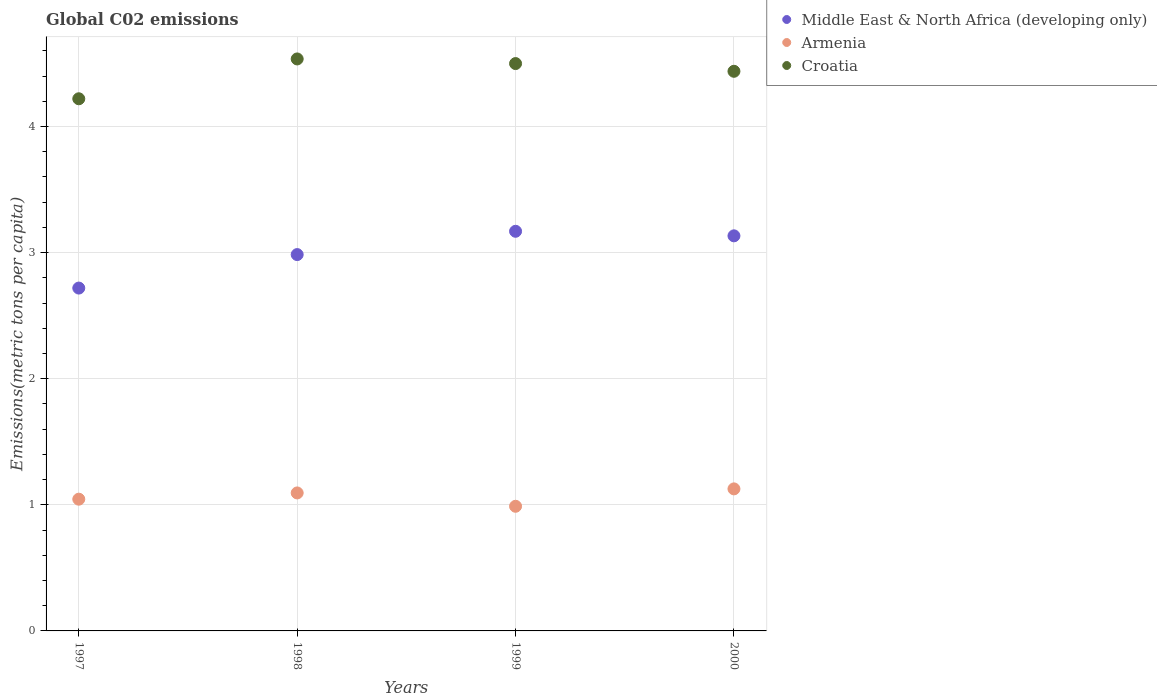What is the amount of CO2 emitted in in Middle East & North Africa (developing only) in 1998?
Provide a succinct answer. 2.98. Across all years, what is the maximum amount of CO2 emitted in in Armenia?
Keep it short and to the point. 1.13. Across all years, what is the minimum amount of CO2 emitted in in Middle East & North Africa (developing only)?
Give a very brief answer. 2.72. What is the total amount of CO2 emitted in in Armenia in the graph?
Your response must be concise. 4.25. What is the difference between the amount of CO2 emitted in in Armenia in 1997 and that in 1998?
Give a very brief answer. -0.05. What is the difference between the amount of CO2 emitted in in Croatia in 1999 and the amount of CO2 emitted in in Armenia in 2000?
Your answer should be compact. 3.37. What is the average amount of CO2 emitted in in Armenia per year?
Ensure brevity in your answer.  1.06. In the year 1999, what is the difference between the amount of CO2 emitted in in Middle East & North Africa (developing only) and amount of CO2 emitted in in Croatia?
Offer a terse response. -1.33. What is the ratio of the amount of CO2 emitted in in Armenia in 1997 to that in 1998?
Your answer should be very brief. 0.95. Is the difference between the amount of CO2 emitted in in Middle East & North Africa (developing only) in 1997 and 2000 greater than the difference between the amount of CO2 emitted in in Croatia in 1997 and 2000?
Make the answer very short. No. What is the difference between the highest and the second highest amount of CO2 emitted in in Croatia?
Your answer should be very brief. 0.04. What is the difference between the highest and the lowest amount of CO2 emitted in in Middle East & North Africa (developing only)?
Give a very brief answer. 0.45. In how many years, is the amount of CO2 emitted in in Middle East & North Africa (developing only) greater than the average amount of CO2 emitted in in Middle East & North Africa (developing only) taken over all years?
Give a very brief answer. 2. Is it the case that in every year, the sum of the amount of CO2 emitted in in Croatia and amount of CO2 emitted in in Middle East & North Africa (developing only)  is greater than the amount of CO2 emitted in in Armenia?
Provide a short and direct response. Yes. Is the amount of CO2 emitted in in Croatia strictly less than the amount of CO2 emitted in in Armenia over the years?
Give a very brief answer. No. How many years are there in the graph?
Ensure brevity in your answer.  4. Are the values on the major ticks of Y-axis written in scientific E-notation?
Provide a succinct answer. No. Where does the legend appear in the graph?
Ensure brevity in your answer.  Top right. How many legend labels are there?
Make the answer very short. 3. What is the title of the graph?
Your answer should be compact. Global C02 emissions. Does "European Union" appear as one of the legend labels in the graph?
Offer a very short reply. No. What is the label or title of the Y-axis?
Give a very brief answer. Emissions(metric tons per capita). What is the Emissions(metric tons per capita) in Middle East & North Africa (developing only) in 1997?
Your response must be concise. 2.72. What is the Emissions(metric tons per capita) in Armenia in 1997?
Your answer should be compact. 1.04. What is the Emissions(metric tons per capita) of Croatia in 1997?
Make the answer very short. 4.22. What is the Emissions(metric tons per capita) in Middle East & North Africa (developing only) in 1998?
Your answer should be very brief. 2.98. What is the Emissions(metric tons per capita) in Armenia in 1998?
Your answer should be compact. 1.09. What is the Emissions(metric tons per capita) in Croatia in 1998?
Ensure brevity in your answer.  4.54. What is the Emissions(metric tons per capita) of Middle East & North Africa (developing only) in 1999?
Make the answer very short. 3.17. What is the Emissions(metric tons per capita) of Armenia in 1999?
Provide a short and direct response. 0.99. What is the Emissions(metric tons per capita) of Croatia in 1999?
Your response must be concise. 4.5. What is the Emissions(metric tons per capita) in Middle East & North Africa (developing only) in 2000?
Offer a very short reply. 3.13. What is the Emissions(metric tons per capita) of Armenia in 2000?
Offer a terse response. 1.13. What is the Emissions(metric tons per capita) of Croatia in 2000?
Offer a terse response. 4.44. Across all years, what is the maximum Emissions(metric tons per capita) of Middle East & North Africa (developing only)?
Offer a very short reply. 3.17. Across all years, what is the maximum Emissions(metric tons per capita) of Armenia?
Provide a succinct answer. 1.13. Across all years, what is the maximum Emissions(metric tons per capita) of Croatia?
Provide a short and direct response. 4.54. Across all years, what is the minimum Emissions(metric tons per capita) in Middle East & North Africa (developing only)?
Your answer should be compact. 2.72. Across all years, what is the minimum Emissions(metric tons per capita) of Armenia?
Your answer should be compact. 0.99. Across all years, what is the minimum Emissions(metric tons per capita) of Croatia?
Your answer should be compact. 4.22. What is the total Emissions(metric tons per capita) in Middle East & North Africa (developing only) in the graph?
Your answer should be compact. 12.01. What is the total Emissions(metric tons per capita) of Armenia in the graph?
Give a very brief answer. 4.25. What is the total Emissions(metric tons per capita) in Croatia in the graph?
Offer a very short reply. 17.69. What is the difference between the Emissions(metric tons per capita) of Middle East & North Africa (developing only) in 1997 and that in 1998?
Give a very brief answer. -0.27. What is the difference between the Emissions(metric tons per capita) of Armenia in 1997 and that in 1998?
Your answer should be very brief. -0.05. What is the difference between the Emissions(metric tons per capita) of Croatia in 1997 and that in 1998?
Your answer should be very brief. -0.32. What is the difference between the Emissions(metric tons per capita) in Middle East & North Africa (developing only) in 1997 and that in 1999?
Your response must be concise. -0.45. What is the difference between the Emissions(metric tons per capita) of Armenia in 1997 and that in 1999?
Your answer should be very brief. 0.06. What is the difference between the Emissions(metric tons per capita) of Croatia in 1997 and that in 1999?
Keep it short and to the point. -0.28. What is the difference between the Emissions(metric tons per capita) of Middle East & North Africa (developing only) in 1997 and that in 2000?
Your response must be concise. -0.41. What is the difference between the Emissions(metric tons per capita) in Armenia in 1997 and that in 2000?
Your response must be concise. -0.08. What is the difference between the Emissions(metric tons per capita) in Croatia in 1997 and that in 2000?
Provide a succinct answer. -0.22. What is the difference between the Emissions(metric tons per capita) of Middle East & North Africa (developing only) in 1998 and that in 1999?
Ensure brevity in your answer.  -0.18. What is the difference between the Emissions(metric tons per capita) of Armenia in 1998 and that in 1999?
Ensure brevity in your answer.  0.11. What is the difference between the Emissions(metric tons per capita) in Croatia in 1998 and that in 1999?
Your answer should be compact. 0.04. What is the difference between the Emissions(metric tons per capita) of Middle East & North Africa (developing only) in 1998 and that in 2000?
Your answer should be compact. -0.15. What is the difference between the Emissions(metric tons per capita) in Armenia in 1998 and that in 2000?
Keep it short and to the point. -0.03. What is the difference between the Emissions(metric tons per capita) of Croatia in 1998 and that in 2000?
Your response must be concise. 0.1. What is the difference between the Emissions(metric tons per capita) in Middle East & North Africa (developing only) in 1999 and that in 2000?
Ensure brevity in your answer.  0.04. What is the difference between the Emissions(metric tons per capita) in Armenia in 1999 and that in 2000?
Give a very brief answer. -0.14. What is the difference between the Emissions(metric tons per capita) of Croatia in 1999 and that in 2000?
Ensure brevity in your answer.  0.06. What is the difference between the Emissions(metric tons per capita) in Middle East & North Africa (developing only) in 1997 and the Emissions(metric tons per capita) in Armenia in 1998?
Offer a very short reply. 1.62. What is the difference between the Emissions(metric tons per capita) in Middle East & North Africa (developing only) in 1997 and the Emissions(metric tons per capita) in Croatia in 1998?
Your answer should be compact. -1.82. What is the difference between the Emissions(metric tons per capita) of Armenia in 1997 and the Emissions(metric tons per capita) of Croatia in 1998?
Keep it short and to the point. -3.49. What is the difference between the Emissions(metric tons per capita) of Middle East & North Africa (developing only) in 1997 and the Emissions(metric tons per capita) of Armenia in 1999?
Your answer should be very brief. 1.73. What is the difference between the Emissions(metric tons per capita) of Middle East & North Africa (developing only) in 1997 and the Emissions(metric tons per capita) of Croatia in 1999?
Offer a very short reply. -1.78. What is the difference between the Emissions(metric tons per capita) in Armenia in 1997 and the Emissions(metric tons per capita) in Croatia in 1999?
Offer a terse response. -3.45. What is the difference between the Emissions(metric tons per capita) in Middle East & North Africa (developing only) in 1997 and the Emissions(metric tons per capita) in Armenia in 2000?
Offer a very short reply. 1.59. What is the difference between the Emissions(metric tons per capita) in Middle East & North Africa (developing only) in 1997 and the Emissions(metric tons per capita) in Croatia in 2000?
Offer a very short reply. -1.72. What is the difference between the Emissions(metric tons per capita) in Armenia in 1997 and the Emissions(metric tons per capita) in Croatia in 2000?
Offer a terse response. -3.39. What is the difference between the Emissions(metric tons per capita) in Middle East & North Africa (developing only) in 1998 and the Emissions(metric tons per capita) in Armenia in 1999?
Offer a terse response. 2. What is the difference between the Emissions(metric tons per capita) in Middle East & North Africa (developing only) in 1998 and the Emissions(metric tons per capita) in Croatia in 1999?
Give a very brief answer. -1.51. What is the difference between the Emissions(metric tons per capita) of Armenia in 1998 and the Emissions(metric tons per capita) of Croatia in 1999?
Your answer should be compact. -3.41. What is the difference between the Emissions(metric tons per capita) of Middle East & North Africa (developing only) in 1998 and the Emissions(metric tons per capita) of Armenia in 2000?
Make the answer very short. 1.86. What is the difference between the Emissions(metric tons per capita) in Middle East & North Africa (developing only) in 1998 and the Emissions(metric tons per capita) in Croatia in 2000?
Make the answer very short. -1.45. What is the difference between the Emissions(metric tons per capita) of Armenia in 1998 and the Emissions(metric tons per capita) of Croatia in 2000?
Give a very brief answer. -3.34. What is the difference between the Emissions(metric tons per capita) in Middle East & North Africa (developing only) in 1999 and the Emissions(metric tons per capita) in Armenia in 2000?
Ensure brevity in your answer.  2.04. What is the difference between the Emissions(metric tons per capita) of Middle East & North Africa (developing only) in 1999 and the Emissions(metric tons per capita) of Croatia in 2000?
Your answer should be compact. -1.27. What is the difference between the Emissions(metric tons per capita) of Armenia in 1999 and the Emissions(metric tons per capita) of Croatia in 2000?
Your response must be concise. -3.45. What is the average Emissions(metric tons per capita) of Middle East & North Africa (developing only) per year?
Your answer should be compact. 3. What is the average Emissions(metric tons per capita) in Armenia per year?
Give a very brief answer. 1.06. What is the average Emissions(metric tons per capita) of Croatia per year?
Your response must be concise. 4.42. In the year 1997, what is the difference between the Emissions(metric tons per capita) in Middle East & North Africa (developing only) and Emissions(metric tons per capita) in Armenia?
Your answer should be very brief. 1.67. In the year 1997, what is the difference between the Emissions(metric tons per capita) in Middle East & North Africa (developing only) and Emissions(metric tons per capita) in Croatia?
Keep it short and to the point. -1.5. In the year 1997, what is the difference between the Emissions(metric tons per capita) of Armenia and Emissions(metric tons per capita) of Croatia?
Provide a succinct answer. -3.18. In the year 1998, what is the difference between the Emissions(metric tons per capita) in Middle East & North Africa (developing only) and Emissions(metric tons per capita) in Armenia?
Your response must be concise. 1.89. In the year 1998, what is the difference between the Emissions(metric tons per capita) of Middle East & North Africa (developing only) and Emissions(metric tons per capita) of Croatia?
Offer a terse response. -1.55. In the year 1998, what is the difference between the Emissions(metric tons per capita) in Armenia and Emissions(metric tons per capita) in Croatia?
Keep it short and to the point. -3.44. In the year 1999, what is the difference between the Emissions(metric tons per capita) in Middle East & North Africa (developing only) and Emissions(metric tons per capita) in Armenia?
Make the answer very short. 2.18. In the year 1999, what is the difference between the Emissions(metric tons per capita) in Middle East & North Africa (developing only) and Emissions(metric tons per capita) in Croatia?
Provide a succinct answer. -1.33. In the year 1999, what is the difference between the Emissions(metric tons per capita) in Armenia and Emissions(metric tons per capita) in Croatia?
Provide a succinct answer. -3.51. In the year 2000, what is the difference between the Emissions(metric tons per capita) in Middle East & North Africa (developing only) and Emissions(metric tons per capita) in Armenia?
Your answer should be very brief. 2.01. In the year 2000, what is the difference between the Emissions(metric tons per capita) of Middle East & North Africa (developing only) and Emissions(metric tons per capita) of Croatia?
Keep it short and to the point. -1.3. In the year 2000, what is the difference between the Emissions(metric tons per capita) in Armenia and Emissions(metric tons per capita) in Croatia?
Offer a very short reply. -3.31. What is the ratio of the Emissions(metric tons per capita) in Middle East & North Africa (developing only) in 1997 to that in 1998?
Your response must be concise. 0.91. What is the ratio of the Emissions(metric tons per capita) in Armenia in 1997 to that in 1998?
Make the answer very short. 0.95. What is the ratio of the Emissions(metric tons per capita) in Croatia in 1997 to that in 1998?
Keep it short and to the point. 0.93. What is the ratio of the Emissions(metric tons per capita) of Middle East & North Africa (developing only) in 1997 to that in 1999?
Your response must be concise. 0.86. What is the ratio of the Emissions(metric tons per capita) of Armenia in 1997 to that in 1999?
Provide a succinct answer. 1.06. What is the ratio of the Emissions(metric tons per capita) in Croatia in 1997 to that in 1999?
Your answer should be very brief. 0.94. What is the ratio of the Emissions(metric tons per capita) in Middle East & North Africa (developing only) in 1997 to that in 2000?
Provide a succinct answer. 0.87. What is the ratio of the Emissions(metric tons per capita) of Armenia in 1997 to that in 2000?
Make the answer very short. 0.93. What is the ratio of the Emissions(metric tons per capita) of Croatia in 1997 to that in 2000?
Offer a terse response. 0.95. What is the ratio of the Emissions(metric tons per capita) of Middle East & North Africa (developing only) in 1998 to that in 1999?
Your response must be concise. 0.94. What is the ratio of the Emissions(metric tons per capita) of Armenia in 1998 to that in 1999?
Your answer should be very brief. 1.11. What is the ratio of the Emissions(metric tons per capita) of Croatia in 1998 to that in 1999?
Your response must be concise. 1.01. What is the ratio of the Emissions(metric tons per capita) in Middle East & North Africa (developing only) in 1998 to that in 2000?
Provide a short and direct response. 0.95. What is the ratio of the Emissions(metric tons per capita) of Armenia in 1998 to that in 2000?
Ensure brevity in your answer.  0.97. What is the ratio of the Emissions(metric tons per capita) of Croatia in 1998 to that in 2000?
Your answer should be compact. 1.02. What is the ratio of the Emissions(metric tons per capita) in Middle East & North Africa (developing only) in 1999 to that in 2000?
Ensure brevity in your answer.  1.01. What is the ratio of the Emissions(metric tons per capita) in Armenia in 1999 to that in 2000?
Your answer should be compact. 0.88. What is the ratio of the Emissions(metric tons per capita) in Croatia in 1999 to that in 2000?
Make the answer very short. 1.01. What is the difference between the highest and the second highest Emissions(metric tons per capita) of Middle East & North Africa (developing only)?
Provide a short and direct response. 0.04. What is the difference between the highest and the second highest Emissions(metric tons per capita) of Armenia?
Ensure brevity in your answer.  0.03. What is the difference between the highest and the second highest Emissions(metric tons per capita) of Croatia?
Your answer should be very brief. 0.04. What is the difference between the highest and the lowest Emissions(metric tons per capita) of Middle East & North Africa (developing only)?
Ensure brevity in your answer.  0.45. What is the difference between the highest and the lowest Emissions(metric tons per capita) of Armenia?
Ensure brevity in your answer.  0.14. What is the difference between the highest and the lowest Emissions(metric tons per capita) in Croatia?
Give a very brief answer. 0.32. 